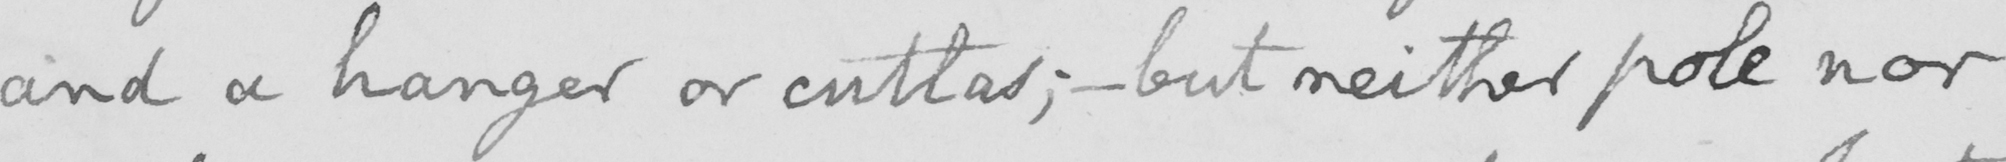What is written in this line of handwriting? and a hanger or cutlas ;  _  but neither pole nor 